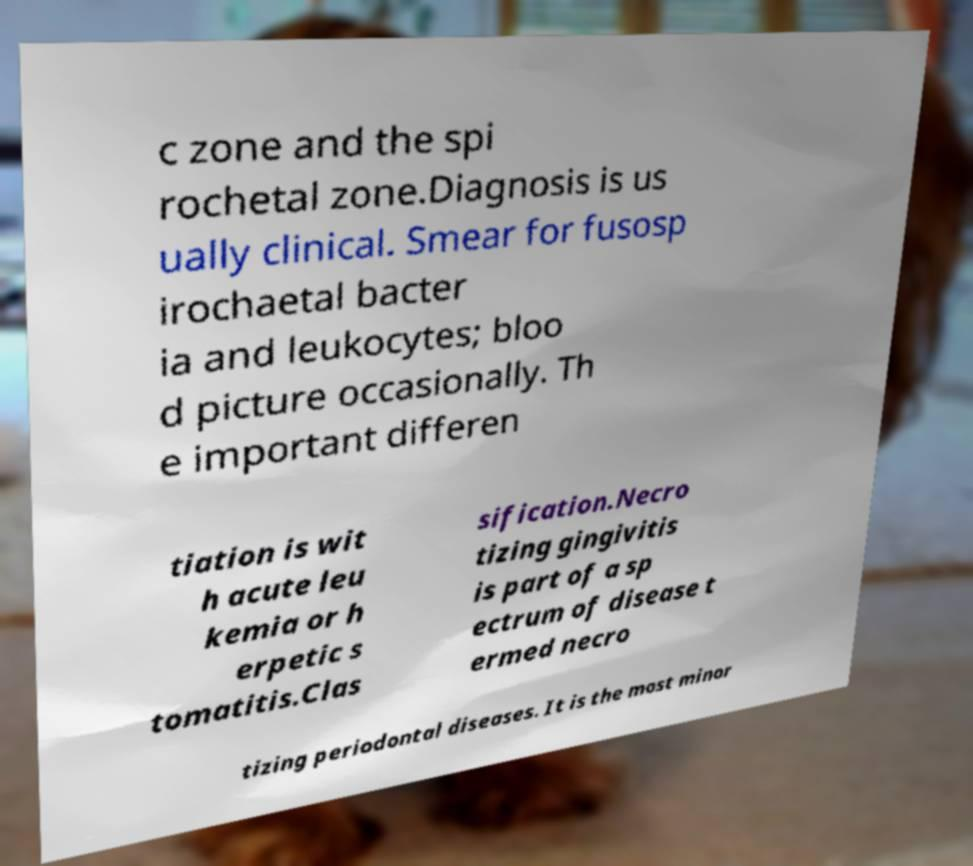Could you extract and type out the text from this image? c zone and the spi rochetal zone.Diagnosis is us ually clinical. Smear for fusosp irochaetal bacter ia and leukocytes; bloo d picture occasionally. Th e important differen tiation is wit h acute leu kemia or h erpetic s tomatitis.Clas sification.Necro tizing gingivitis is part of a sp ectrum of disease t ermed necro tizing periodontal diseases. It is the most minor 